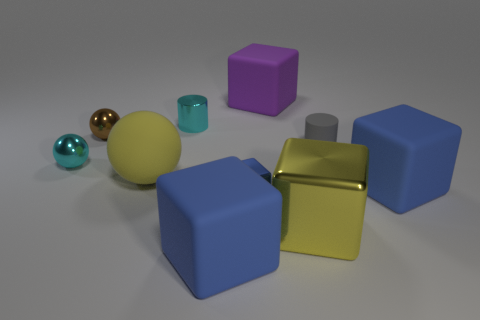Subtract all yellow cubes. How many cubes are left? 4 Subtract 2 balls. How many balls are left? 1 Subtract all purple blocks. How many blocks are left? 4 Subtract all balls. How many objects are left? 7 Subtract all gray blocks. How many purple cylinders are left? 0 Subtract all big purple rubber cubes. Subtract all rubber cylinders. How many objects are left? 8 Add 1 metal objects. How many metal objects are left? 6 Add 7 large yellow matte objects. How many large yellow matte objects exist? 8 Subtract 0 red cylinders. How many objects are left? 10 Subtract all red cylinders. Subtract all brown blocks. How many cylinders are left? 2 